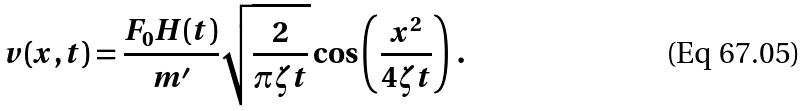<formula> <loc_0><loc_0><loc_500><loc_500>v ( x , t ) = \frac { F _ { 0 } H ( t ) } { m ^ { \prime } } \sqrt { \frac { 2 } { \pi \zeta t } } \cos \left ( \frac { x ^ { 2 } } { 4 \zeta t } \right ) \, .</formula> 